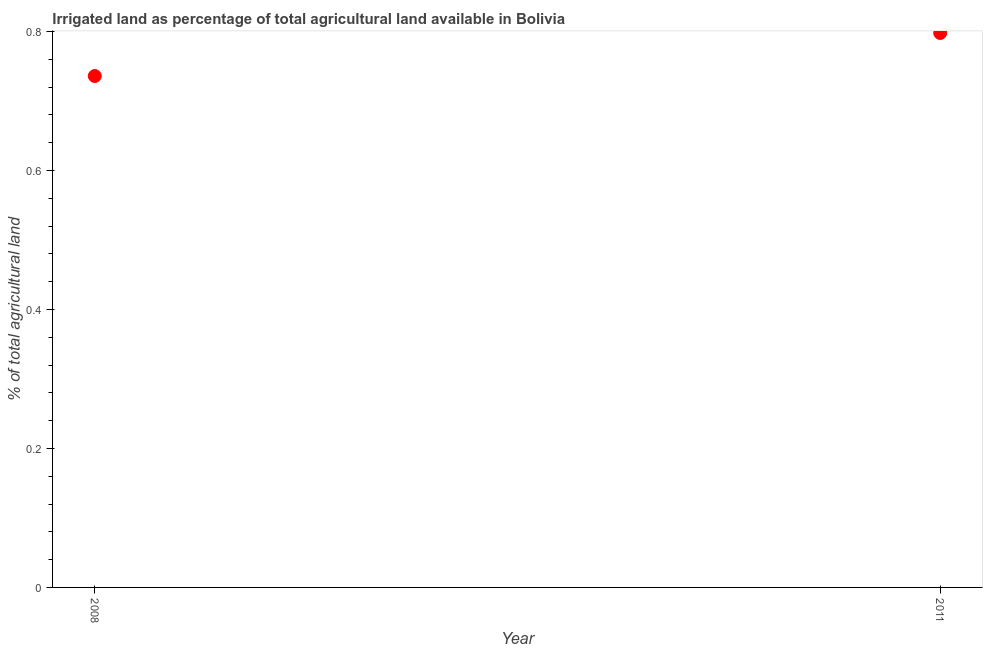What is the percentage of agricultural irrigated land in 2008?
Keep it short and to the point. 0.74. Across all years, what is the maximum percentage of agricultural irrigated land?
Your answer should be compact. 0.8. Across all years, what is the minimum percentage of agricultural irrigated land?
Give a very brief answer. 0.74. In which year was the percentage of agricultural irrigated land maximum?
Ensure brevity in your answer.  2011. What is the sum of the percentage of agricultural irrigated land?
Keep it short and to the point. 1.53. What is the difference between the percentage of agricultural irrigated land in 2008 and 2011?
Your answer should be compact. -0.06. What is the average percentage of agricultural irrigated land per year?
Provide a short and direct response. 0.77. What is the median percentage of agricultural irrigated land?
Offer a very short reply. 0.77. What is the ratio of the percentage of agricultural irrigated land in 2008 to that in 2011?
Your answer should be compact. 0.92. Is the percentage of agricultural irrigated land in 2008 less than that in 2011?
Offer a terse response. Yes. Does the percentage of agricultural irrigated land monotonically increase over the years?
Offer a terse response. Yes. How many dotlines are there?
Provide a short and direct response. 1. Are the values on the major ticks of Y-axis written in scientific E-notation?
Your response must be concise. No. What is the title of the graph?
Make the answer very short. Irrigated land as percentage of total agricultural land available in Bolivia. What is the label or title of the X-axis?
Your answer should be compact. Year. What is the label or title of the Y-axis?
Your response must be concise. % of total agricultural land. What is the % of total agricultural land in 2008?
Offer a very short reply. 0.74. What is the % of total agricultural land in 2011?
Your answer should be very brief. 0.8. What is the difference between the % of total agricultural land in 2008 and 2011?
Offer a very short reply. -0.06. What is the ratio of the % of total agricultural land in 2008 to that in 2011?
Offer a terse response. 0.92. 